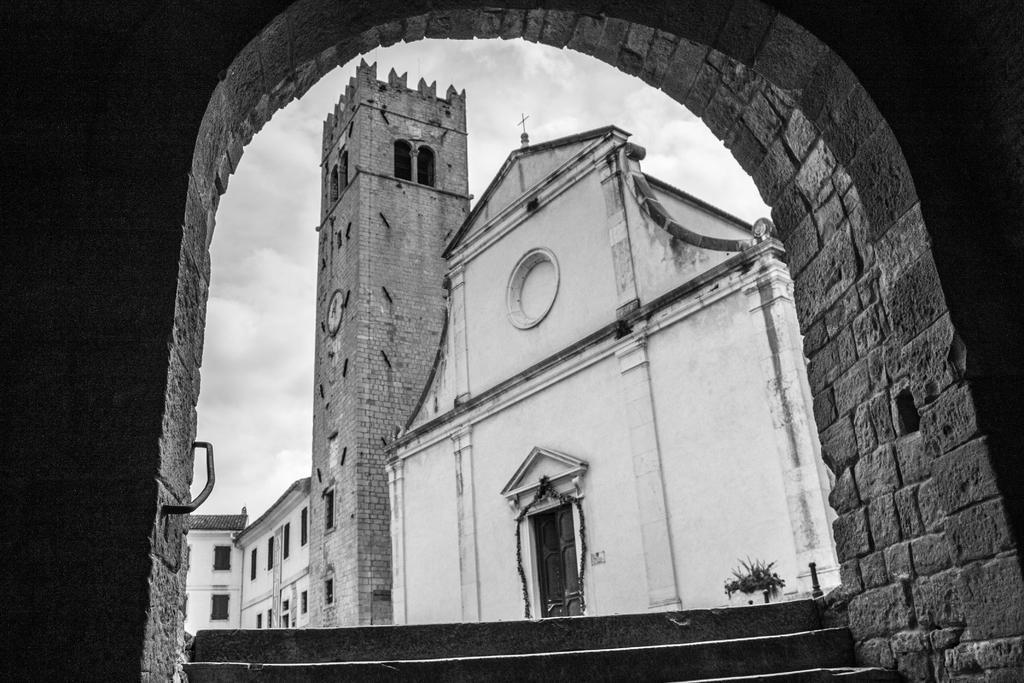Could you give a brief overview of what you see in this image? This is a black and white image. In this image we can see some buildings with windows and a door. We can also see a plant in a pot, a staircase, a tower with a clock, an arch and the sky which looks cloudy. 